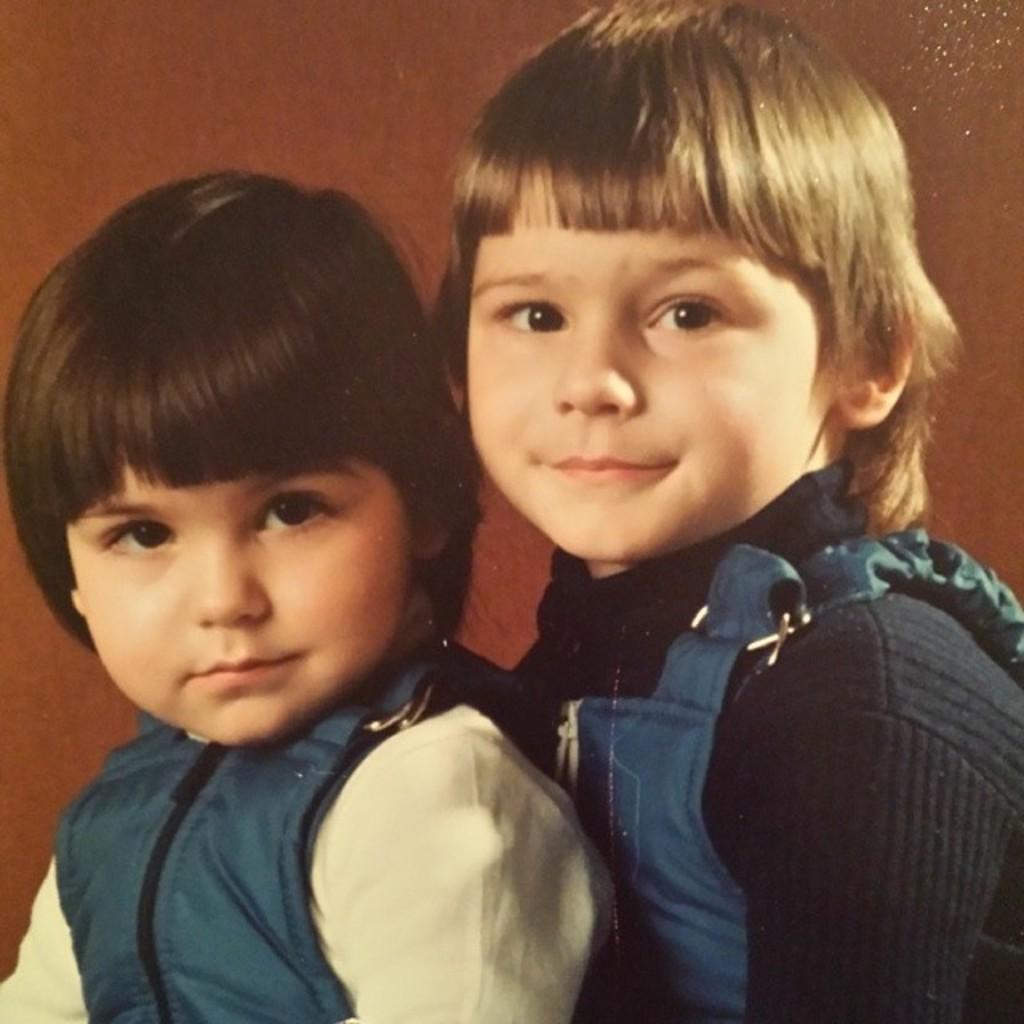How would you summarize this image in a sentence or two? In this image, I can see two kids and there is a brown background. 